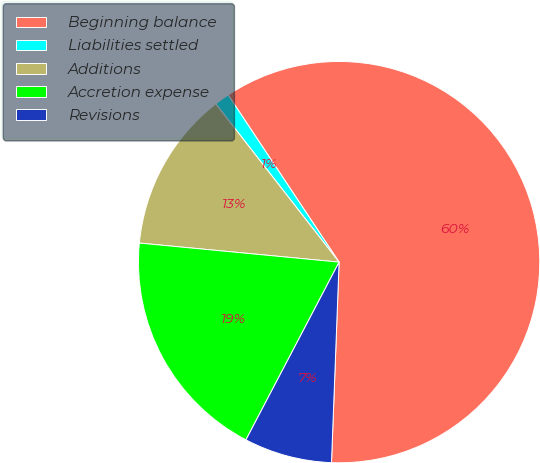Convert chart to OTSL. <chart><loc_0><loc_0><loc_500><loc_500><pie_chart><fcel>Beginning balance<fcel>Liabilities settled<fcel>Additions<fcel>Accretion expense<fcel>Revisions<nl><fcel>59.93%<fcel>1.21%<fcel>12.95%<fcel>18.83%<fcel>7.08%<nl></chart> 